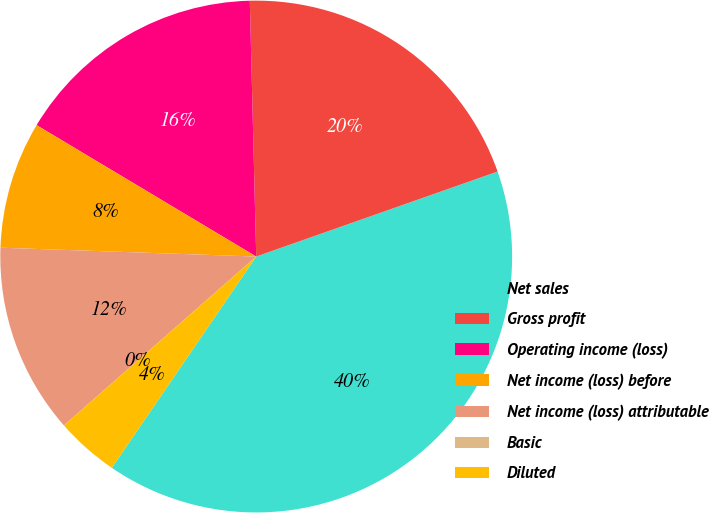<chart> <loc_0><loc_0><loc_500><loc_500><pie_chart><fcel>Net sales<fcel>Gross profit<fcel>Operating income (loss)<fcel>Net income (loss) before<fcel>Net income (loss) attributable<fcel>Basic<fcel>Diluted<nl><fcel>39.93%<fcel>20.01%<fcel>16.02%<fcel>8.03%<fcel>12.02%<fcel>0.0%<fcel>3.99%<nl></chart> 